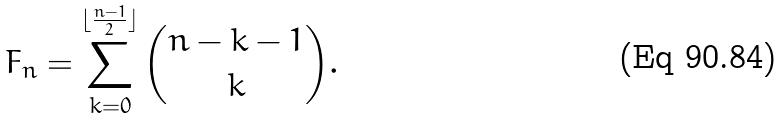Convert formula to latex. <formula><loc_0><loc_0><loc_500><loc_500>F _ { n } = \sum _ { k = 0 } ^ { \lfloor \frac { n - 1 } { 2 } \rfloor } { n - k - 1 \choose k } .</formula> 